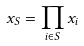Convert formula to latex. <formula><loc_0><loc_0><loc_500><loc_500>x _ { S } = \prod _ { i \in S } x _ { i }</formula> 